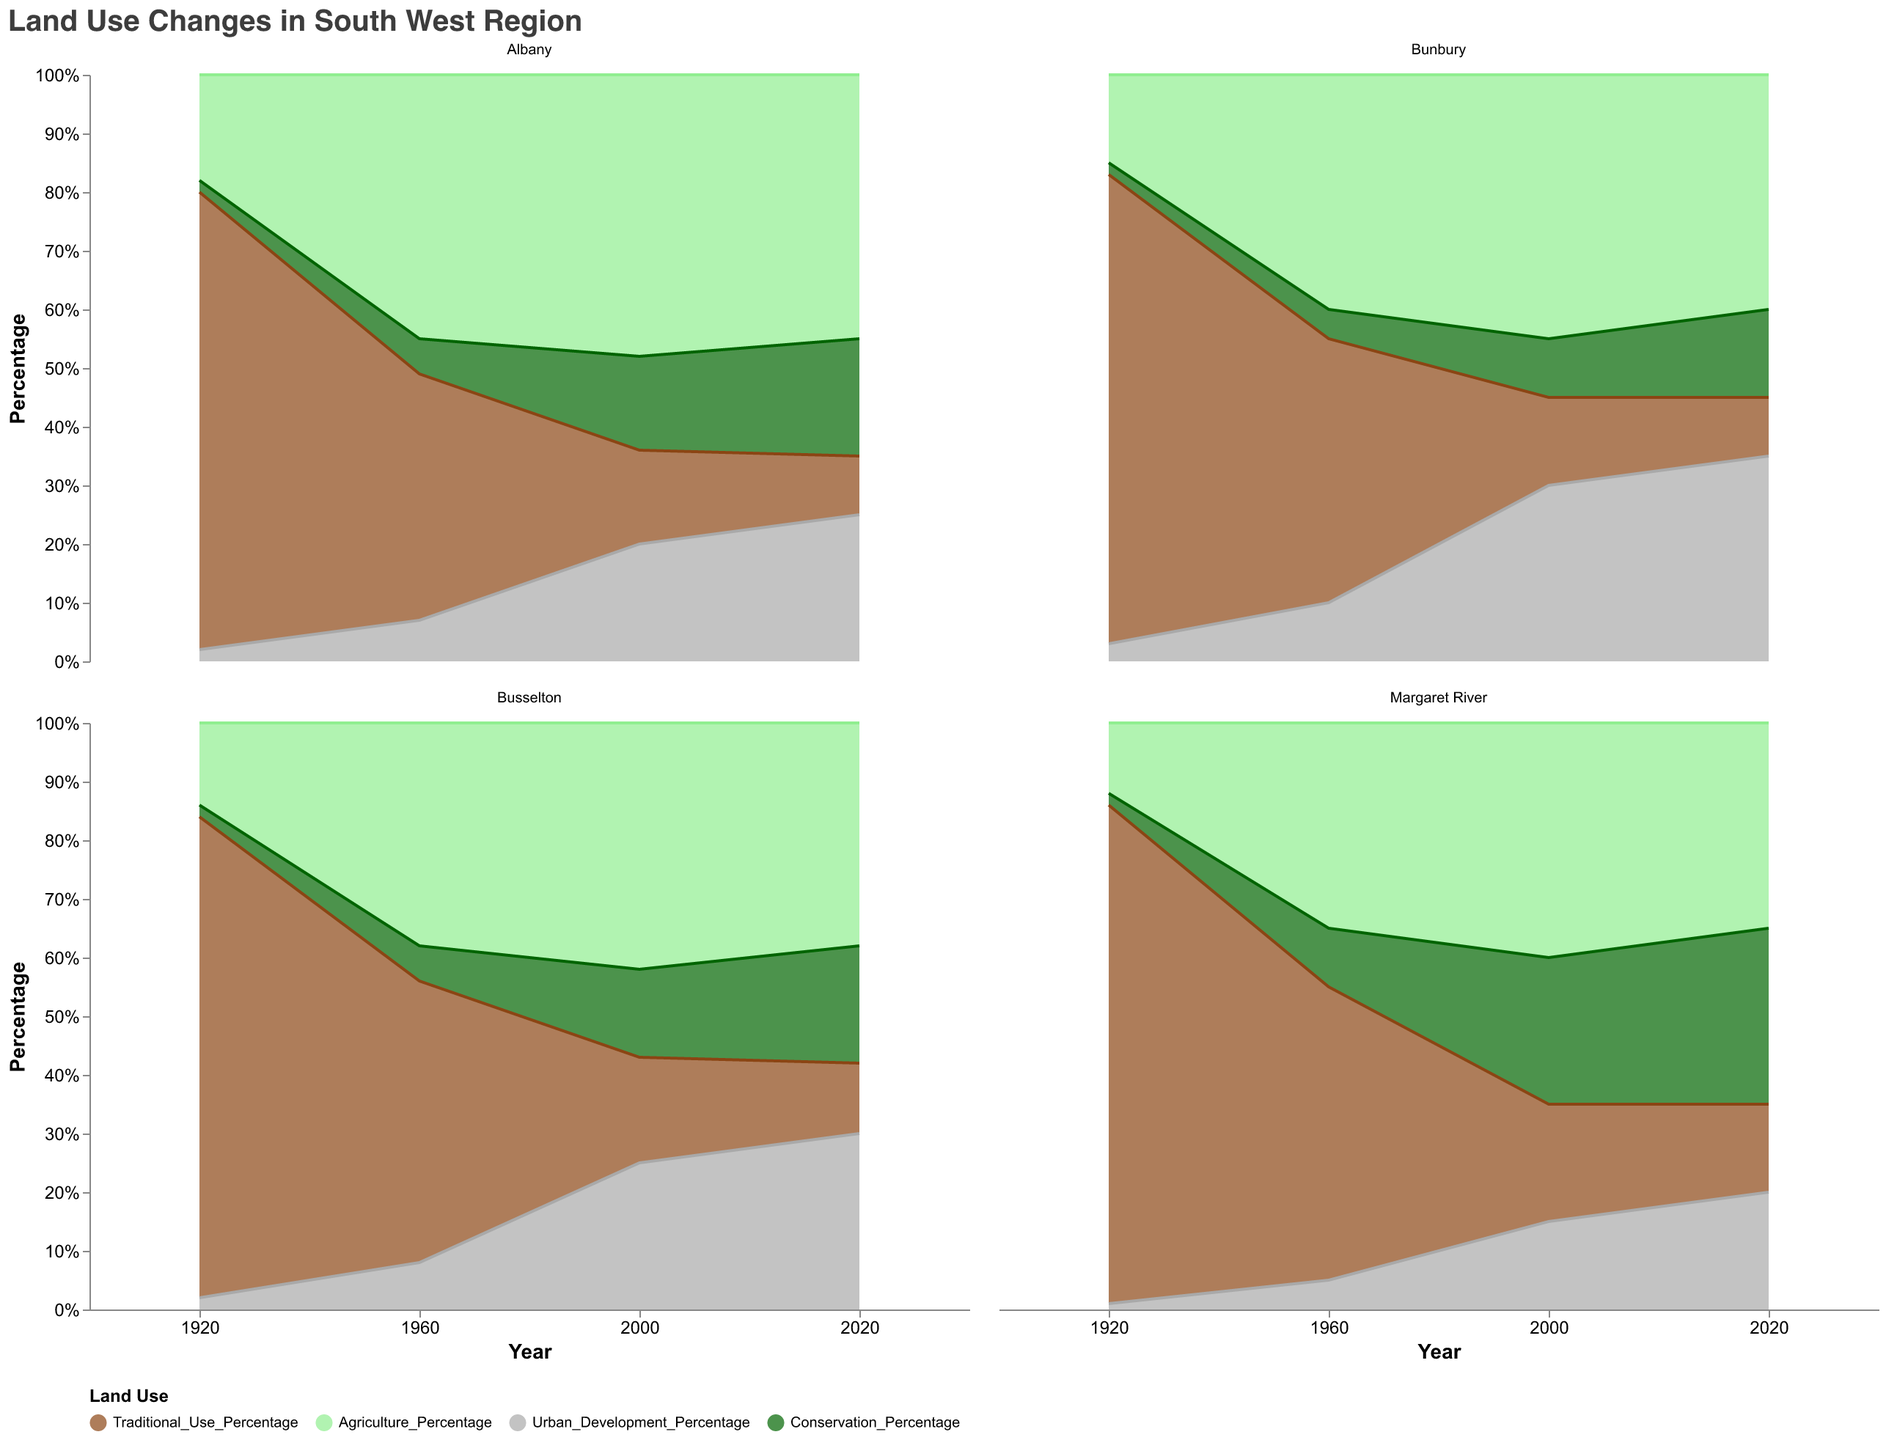What is the title of the figure? By examining the rendered figure, observe the text at the top that represents the title.
Answer: Land Use Changes in South West Region Which region had the highest percentage of traditional use in 1920? Look at the data for 1920 and compare the traditional use percentages for Bunbury, Margaret River, Busselton, and Albany.
Answer: Margaret River How did urban development change in Bunbury from 1920 to 2020? Observe the values for urban development in Bunbury across the years 1920, 1960, 2000, and 2020. Note the values and calculate the difference between 2020 and 1920.
Answer: Increased by 32% Which region showed the highest conservation percentage in 2020? Compare the conservation percentages for all regions in 2020. Identify the region with the highest percentage.
Answer: Margaret River What is the trend in traditional use percentage for Busselton over the four marked years? Observe the traditional use percentages for Busselton in 1920, 1960, 2000, and 2020. Note the direction of the trend in percentages over these years.
Answer: Decreasing trend How did agricultural land usage change in Albany between 1960 and 2000? Compare the agriculture percentages for Albany in 1960 and 2000. Note the values and calculate the difference between these years.
Answer: Increased by 3% What percentage of Bunbury's land was used for conservation in 2020? Look at the conservation percentage for Bunbury in the year 2020.
Answer: 15% Which region had the most significant decrease in traditional use percentage from 1920 to 2020? Calculate the difference in traditional use percentages from 1920 to 2020 for each region. Identify the region with the largest decrease.
Answer: Bunbury In which year did Margaret River have the highest percentage of land used for conservation? Compare the conservation percentages for Margaret River across the years 1920, 1960, 2000, and 2020. Identify the highest value.
Answer: 2020 